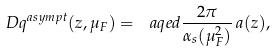Convert formula to latex. <formula><loc_0><loc_0><loc_500><loc_500>\ D q ^ { a s y m p t } ( z , \mu _ { F } ) = \ a q e d \frac { 2 \pi } { \alpha _ { s } ( \mu _ { F } ^ { 2 } ) } \, a ( z ) ,</formula> 